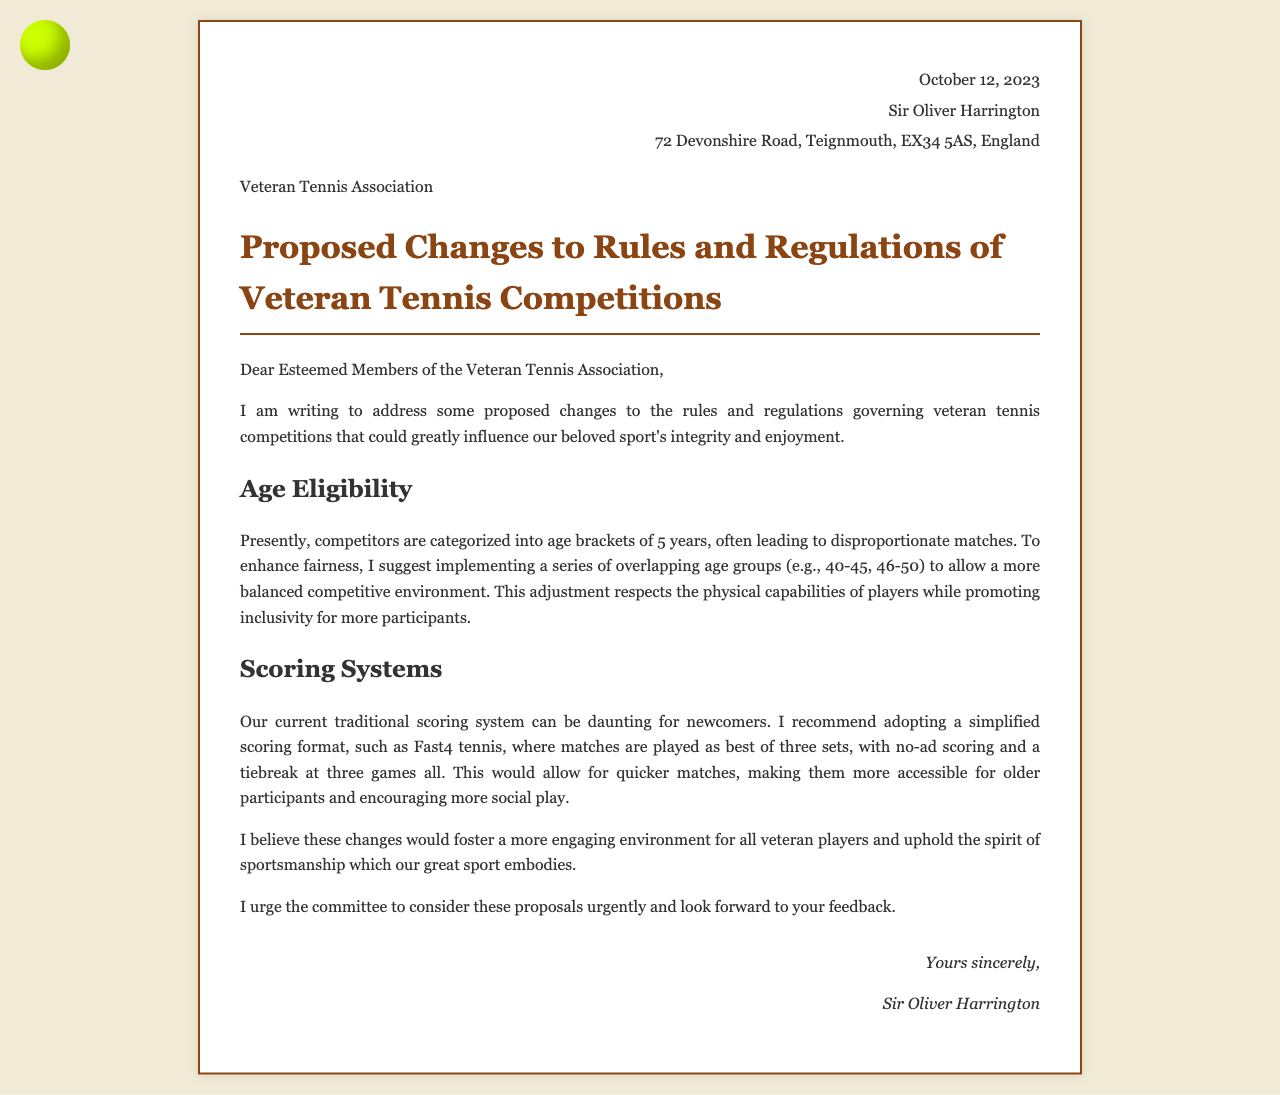What is the date of the letter? The date of the letter is mentioned at the top of the document.
Answer: October 12, 2023 Who is the author of the letter? The author is introduced in the header section of the document.
Answer: Sir Oliver Harrington What is the main topic addressed in the letter? The topic is introduced in the title of the letter.
Answer: Proposed Changes to Rules and Regulations of Veteran Tennis Competitions What age brackets are currently used in competitions? The current age categories are described in the Age Eligibility section.
Answer: 5 years What scoring system does Sir Oliver recommend? The recommended scoring system is detailed in the Scoring Systems section.
Answer: Fast4 tennis What are the proposed overlapping age groups mentioned? The suggestion for age brackets is given in the Age Eligibility section.
Answer: 40-45, 46-50 What is the purpose of the proposed changes? The purpose is described in the opening and concluding sections of the letter.
Answer: Enhance fairness How does Sir Oliver suggest simplifying matches? The suggestion is made in the Scoring Systems section.
Answer: Quicker matches What is Sir Oliver's request to the committee? The request is found towards the end of the letter.
Answer: Urgently consider these proposals 